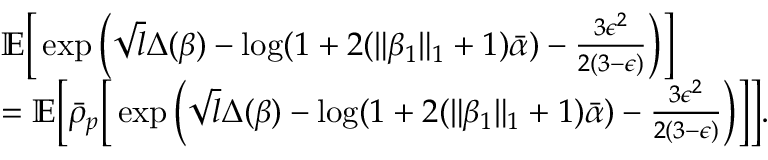<formula> <loc_0><loc_0><loc_500><loc_500>\begin{array} { r l } & { \mathbb { E } \left [ \exp \left ( \sqrt { l } \Delta ( \beta ) - \log ( 1 + 2 ( \| \beta _ { 1 } \| _ { 1 } + 1 ) \bar { \alpha } ) - \frac { 3 \epsilon ^ { 2 } } { 2 ( 3 - \epsilon ) } \right ) \right ] } \\ & { = \mathbb { E } \left [ \bar { \rho } _ { p } \left [ \exp \left ( \sqrt { l } \Delta ( \beta ) - \log ( 1 + 2 ( \| \beta _ { 1 } \| _ { 1 } + 1 ) \bar { \alpha } ) - \frac { 3 \epsilon ^ { 2 } } { 2 ( 3 - \epsilon ) } \right ) \right ] \right ] . } \end{array}</formula> 